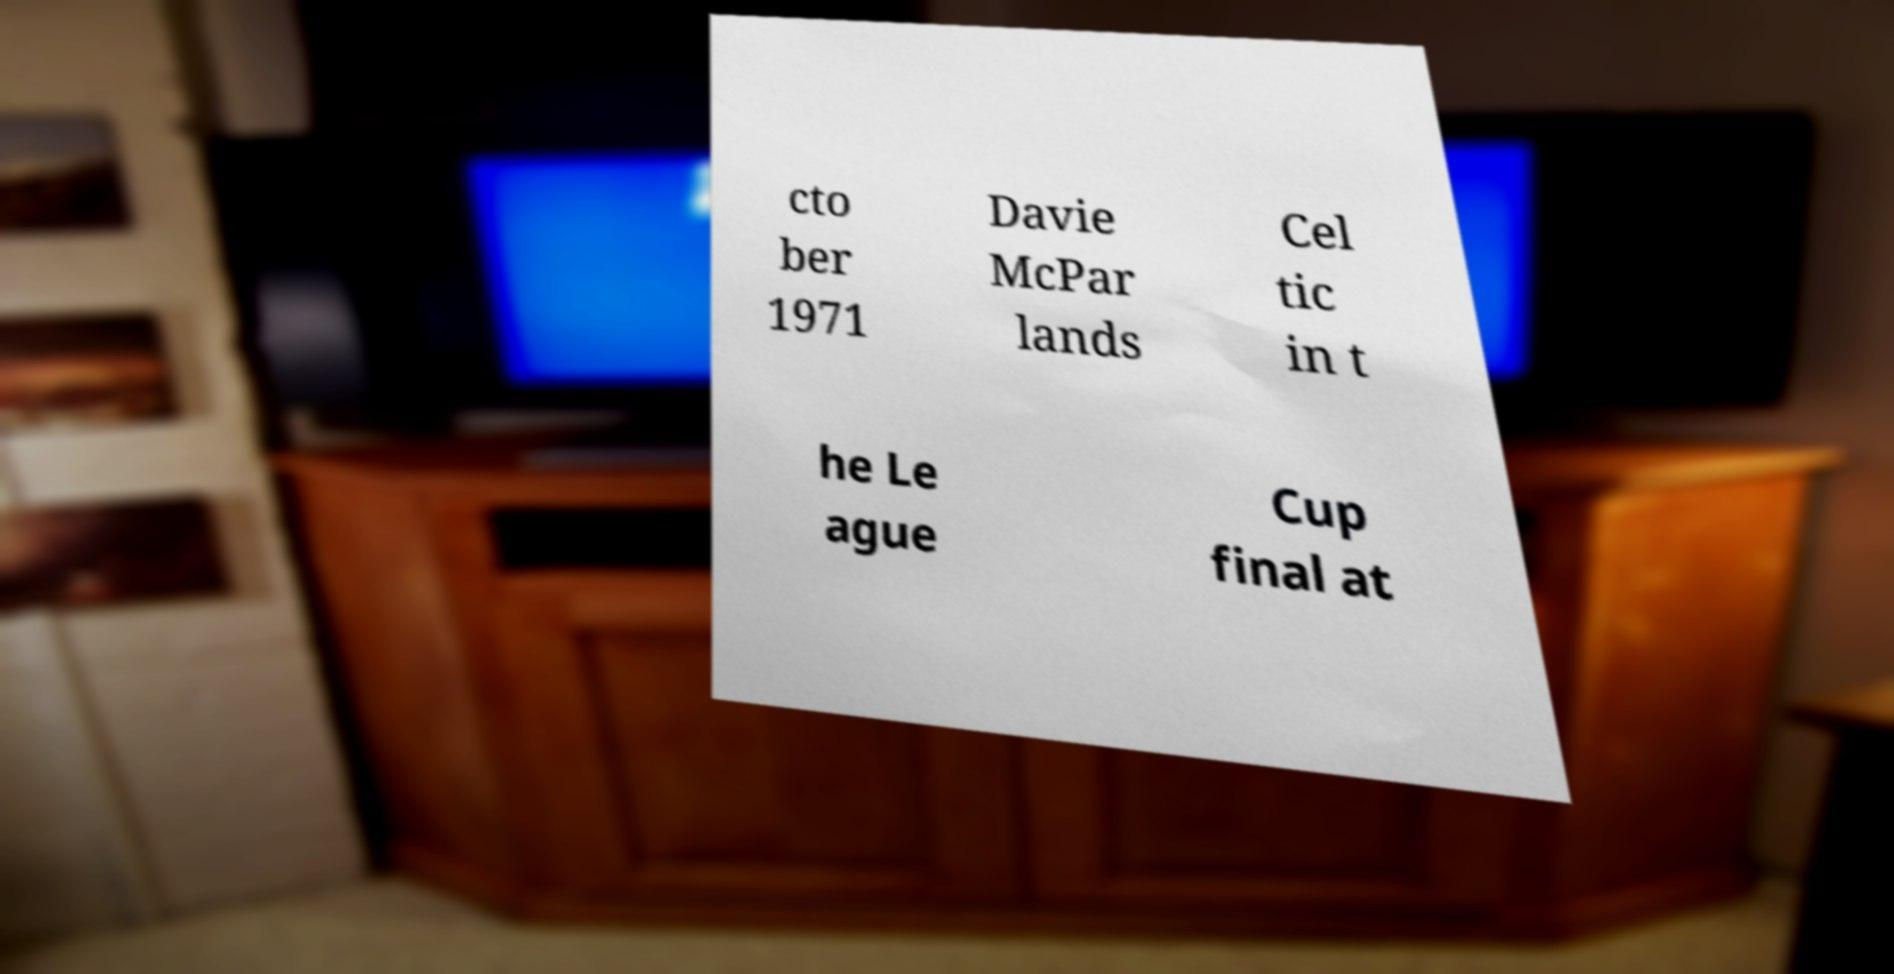Could you assist in decoding the text presented in this image and type it out clearly? cto ber 1971 Davie McPar lands Cel tic in t he Le ague Cup final at 